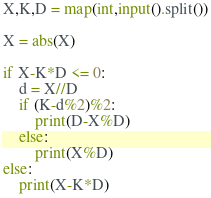<code> <loc_0><loc_0><loc_500><loc_500><_Python_>X,K,D = map(int,input().split())

X = abs(X)

if X-K*D <= 0:
    d = X//D
    if (K-d%2)%2:
        print(D-X%D)
    else:
        print(X%D)
else:
    print(X-K*D)
</code> 